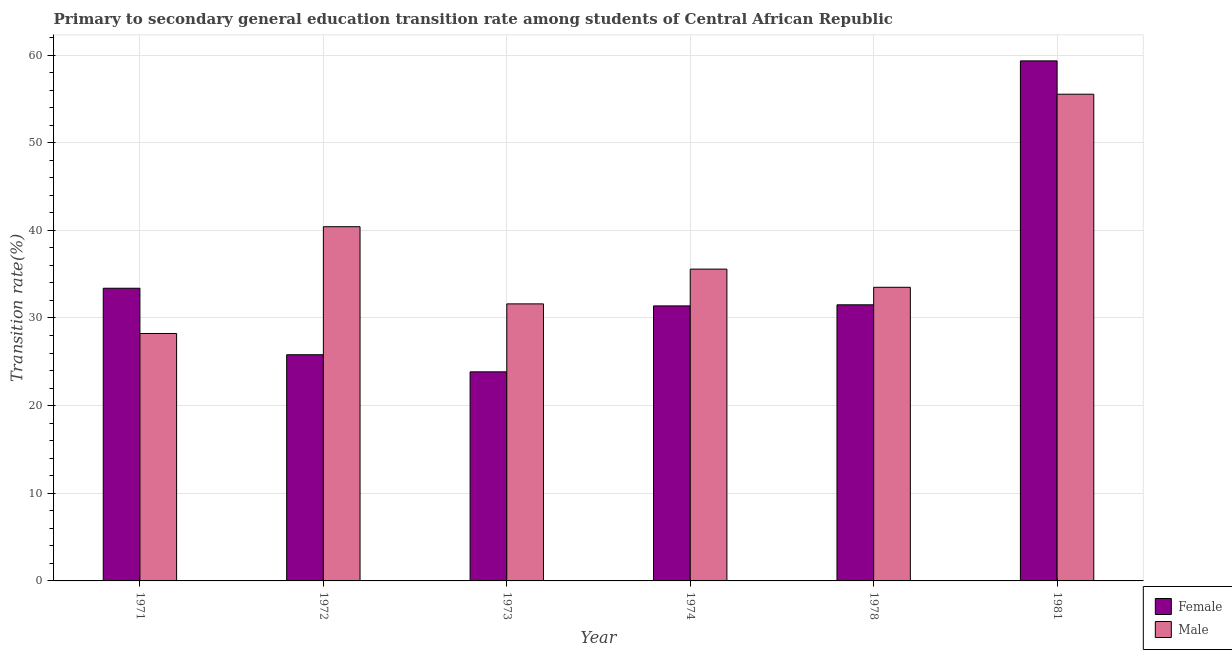How many groups of bars are there?
Give a very brief answer. 6. Are the number of bars per tick equal to the number of legend labels?
Your answer should be very brief. Yes. How many bars are there on the 4th tick from the right?
Your answer should be compact. 2. What is the label of the 6th group of bars from the left?
Offer a very short reply. 1981. In how many cases, is the number of bars for a given year not equal to the number of legend labels?
Your answer should be compact. 0. What is the transition rate among female students in 1974?
Provide a succinct answer. 31.38. Across all years, what is the maximum transition rate among male students?
Your response must be concise. 55.53. Across all years, what is the minimum transition rate among female students?
Provide a succinct answer. 23.85. In which year was the transition rate among female students maximum?
Your answer should be compact. 1981. What is the total transition rate among male students in the graph?
Provide a short and direct response. 224.85. What is the difference between the transition rate among male students in 1971 and that in 1978?
Your answer should be compact. -5.27. What is the difference between the transition rate among female students in 1972 and the transition rate among male students in 1981?
Provide a succinct answer. -33.53. What is the average transition rate among female students per year?
Ensure brevity in your answer.  34.21. In the year 1973, what is the difference between the transition rate among male students and transition rate among female students?
Your answer should be very brief. 0. In how many years, is the transition rate among female students greater than 52 %?
Provide a succinct answer. 1. What is the ratio of the transition rate among female students in 1973 to that in 1981?
Your answer should be compact. 0.4. Is the transition rate among female students in 1972 less than that in 1978?
Provide a short and direct response. Yes. What is the difference between the highest and the second highest transition rate among female students?
Keep it short and to the point. 25.94. What is the difference between the highest and the lowest transition rate among male students?
Provide a succinct answer. 27.3. What does the 1st bar from the right in 1973 represents?
Make the answer very short. Male. How many bars are there?
Make the answer very short. 12. Does the graph contain grids?
Offer a terse response. Yes. How are the legend labels stacked?
Offer a very short reply. Vertical. What is the title of the graph?
Keep it short and to the point. Primary to secondary general education transition rate among students of Central African Republic. Does "Money lenders" appear as one of the legend labels in the graph?
Provide a short and direct response. No. What is the label or title of the Y-axis?
Make the answer very short. Transition rate(%). What is the Transition rate(%) in Female in 1971?
Provide a short and direct response. 33.39. What is the Transition rate(%) of Male in 1971?
Offer a very short reply. 28.23. What is the Transition rate(%) in Female in 1972?
Provide a short and direct response. 25.81. What is the Transition rate(%) in Male in 1972?
Provide a short and direct response. 40.41. What is the Transition rate(%) of Female in 1973?
Ensure brevity in your answer.  23.85. What is the Transition rate(%) in Male in 1973?
Your response must be concise. 31.61. What is the Transition rate(%) in Female in 1974?
Ensure brevity in your answer.  31.38. What is the Transition rate(%) in Male in 1974?
Ensure brevity in your answer.  35.57. What is the Transition rate(%) in Female in 1978?
Provide a succinct answer. 31.5. What is the Transition rate(%) in Male in 1978?
Offer a very short reply. 33.5. What is the Transition rate(%) of Female in 1981?
Your response must be concise. 59.33. What is the Transition rate(%) in Male in 1981?
Your response must be concise. 55.53. Across all years, what is the maximum Transition rate(%) in Female?
Ensure brevity in your answer.  59.33. Across all years, what is the maximum Transition rate(%) in Male?
Make the answer very short. 55.53. Across all years, what is the minimum Transition rate(%) of Female?
Your answer should be very brief. 23.85. Across all years, what is the minimum Transition rate(%) of Male?
Provide a short and direct response. 28.23. What is the total Transition rate(%) of Female in the graph?
Your response must be concise. 205.26. What is the total Transition rate(%) of Male in the graph?
Make the answer very short. 224.85. What is the difference between the Transition rate(%) in Female in 1971 and that in 1972?
Provide a succinct answer. 7.58. What is the difference between the Transition rate(%) in Male in 1971 and that in 1972?
Ensure brevity in your answer.  -12.18. What is the difference between the Transition rate(%) of Female in 1971 and that in 1973?
Make the answer very short. 9.54. What is the difference between the Transition rate(%) in Male in 1971 and that in 1973?
Ensure brevity in your answer.  -3.38. What is the difference between the Transition rate(%) in Female in 1971 and that in 1974?
Your response must be concise. 2.01. What is the difference between the Transition rate(%) in Male in 1971 and that in 1974?
Your answer should be very brief. -7.34. What is the difference between the Transition rate(%) of Female in 1971 and that in 1978?
Your answer should be very brief. 1.89. What is the difference between the Transition rate(%) of Male in 1971 and that in 1978?
Make the answer very short. -5.27. What is the difference between the Transition rate(%) in Female in 1971 and that in 1981?
Your answer should be very brief. -25.94. What is the difference between the Transition rate(%) of Male in 1971 and that in 1981?
Your answer should be compact. -27.3. What is the difference between the Transition rate(%) of Female in 1972 and that in 1973?
Provide a short and direct response. 1.95. What is the difference between the Transition rate(%) in Male in 1972 and that in 1973?
Provide a short and direct response. 8.8. What is the difference between the Transition rate(%) in Female in 1972 and that in 1974?
Your answer should be compact. -5.57. What is the difference between the Transition rate(%) in Male in 1972 and that in 1974?
Offer a terse response. 4.84. What is the difference between the Transition rate(%) in Female in 1972 and that in 1978?
Your answer should be compact. -5.7. What is the difference between the Transition rate(%) of Male in 1972 and that in 1978?
Provide a short and direct response. 6.91. What is the difference between the Transition rate(%) of Female in 1972 and that in 1981?
Your answer should be compact. -33.53. What is the difference between the Transition rate(%) of Male in 1972 and that in 1981?
Keep it short and to the point. -15.12. What is the difference between the Transition rate(%) in Female in 1973 and that in 1974?
Provide a short and direct response. -7.52. What is the difference between the Transition rate(%) in Male in 1973 and that in 1974?
Your response must be concise. -3.97. What is the difference between the Transition rate(%) of Female in 1973 and that in 1978?
Offer a terse response. -7.65. What is the difference between the Transition rate(%) in Male in 1973 and that in 1978?
Ensure brevity in your answer.  -1.89. What is the difference between the Transition rate(%) of Female in 1973 and that in 1981?
Your response must be concise. -35.48. What is the difference between the Transition rate(%) of Male in 1973 and that in 1981?
Your answer should be very brief. -23.92. What is the difference between the Transition rate(%) of Female in 1974 and that in 1978?
Your response must be concise. -0.12. What is the difference between the Transition rate(%) in Male in 1974 and that in 1978?
Ensure brevity in your answer.  2.07. What is the difference between the Transition rate(%) in Female in 1974 and that in 1981?
Keep it short and to the point. -27.96. What is the difference between the Transition rate(%) in Male in 1974 and that in 1981?
Your answer should be very brief. -19.95. What is the difference between the Transition rate(%) of Female in 1978 and that in 1981?
Make the answer very short. -27.83. What is the difference between the Transition rate(%) in Male in 1978 and that in 1981?
Offer a very short reply. -22.03. What is the difference between the Transition rate(%) in Female in 1971 and the Transition rate(%) in Male in 1972?
Give a very brief answer. -7.02. What is the difference between the Transition rate(%) in Female in 1971 and the Transition rate(%) in Male in 1973?
Make the answer very short. 1.78. What is the difference between the Transition rate(%) in Female in 1971 and the Transition rate(%) in Male in 1974?
Your answer should be very brief. -2.18. What is the difference between the Transition rate(%) of Female in 1971 and the Transition rate(%) of Male in 1978?
Ensure brevity in your answer.  -0.11. What is the difference between the Transition rate(%) in Female in 1971 and the Transition rate(%) in Male in 1981?
Make the answer very short. -22.14. What is the difference between the Transition rate(%) in Female in 1972 and the Transition rate(%) in Male in 1973?
Offer a very short reply. -5.8. What is the difference between the Transition rate(%) in Female in 1972 and the Transition rate(%) in Male in 1974?
Ensure brevity in your answer.  -9.77. What is the difference between the Transition rate(%) in Female in 1972 and the Transition rate(%) in Male in 1978?
Your response must be concise. -7.69. What is the difference between the Transition rate(%) in Female in 1972 and the Transition rate(%) in Male in 1981?
Ensure brevity in your answer.  -29.72. What is the difference between the Transition rate(%) of Female in 1973 and the Transition rate(%) of Male in 1974?
Your response must be concise. -11.72. What is the difference between the Transition rate(%) in Female in 1973 and the Transition rate(%) in Male in 1978?
Keep it short and to the point. -9.65. What is the difference between the Transition rate(%) of Female in 1973 and the Transition rate(%) of Male in 1981?
Offer a terse response. -31.68. What is the difference between the Transition rate(%) in Female in 1974 and the Transition rate(%) in Male in 1978?
Your response must be concise. -2.12. What is the difference between the Transition rate(%) of Female in 1974 and the Transition rate(%) of Male in 1981?
Provide a short and direct response. -24.15. What is the difference between the Transition rate(%) of Female in 1978 and the Transition rate(%) of Male in 1981?
Offer a very short reply. -24.03. What is the average Transition rate(%) of Female per year?
Your answer should be very brief. 34.21. What is the average Transition rate(%) of Male per year?
Offer a very short reply. 37.48. In the year 1971, what is the difference between the Transition rate(%) in Female and Transition rate(%) in Male?
Offer a very short reply. 5.16. In the year 1972, what is the difference between the Transition rate(%) of Female and Transition rate(%) of Male?
Your answer should be compact. -14.61. In the year 1973, what is the difference between the Transition rate(%) in Female and Transition rate(%) in Male?
Your response must be concise. -7.75. In the year 1974, what is the difference between the Transition rate(%) of Female and Transition rate(%) of Male?
Provide a short and direct response. -4.2. In the year 1978, what is the difference between the Transition rate(%) in Female and Transition rate(%) in Male?
Provide a short and direct response. -2. In the year 1981, what is the difference between the Transition rate(%) in Female and Transition rate(%) in Male?
Give a very brief answer. 3.8. What is the ratio of the Transition rate(%) of Female in 1971 to that in 1972?
Your answer should be very brief. 1.29. What is the ratio of the Transition rate(%) in Male in 1971 to that in 1972?
Keep it short and to the point. 0.7. What is the ratio of the Transition rate(%) in Female in 1971 to that in 1973?
Your answer should be compact. 1.4. What is the ratio of the Transition rate(%) of Male in 1971 to that in 1973?
Ensure brevity in your answer.  0.89. What is the ratio of the Transition rate(%) of Female in 1971 to that in 1974?
Your answer should be very brief. 1.06. What is the ratio of the Transition rate(%) of Male in 1971 to that in 1974?
Provide a short and direct response. 0.79. What is the ratio of the Transition rate(%) in Female in 1971 to that in 1978?
Make the answer very short. 1.06. What is the ratio of the Transition rate(%) of Male in 1971 to that in 1978?
Your answer should be compact. 0.84. What is the ratio of the Transition rate(%) of Female in 1971 to that in 1981?
Provide a succinct answer. 0.56. What is the ratio of the Transition rate(%) in Male in 1971 to that in 1981?
Offer a terse response. 0.51. What is the ratio of the Transition rate(%) in Female in 1972 to that in 1973?
Offer a very short reply. 1.08. What is the ratio of the Transition rate(%) of Male in 1972 to that in 1973?
Offer a terse response. 1.28. What is the ratio of the Transition rate(%) of Female in 1972 to that in 1974?
Offer a very short reply. 0.82. What is the ratio of the Transition rate(%) in Male in 1972 to that in 1974?
Give a very brief answer. 1.14. What is the ratio of the Transition rate(%) in Female in 1972 to that in 1978?
Provide a short and direct response. 0.82. What is the ratio of the Transition rate(%) of Male in 1972 to that in 1978?
Provide a short and direct response. 1.21. What is the ratio of the Transition rate(%) in Female in 1972 to that in 1981?
Offer a very short reply. 0.43. What is the ratio of the Transition rate(%) of Male in 1972 to that in 1981?
Your answer should be very brief. 0.73. What is the ratio of the Transition rate(%) of Female in 1973 to that in 1974?
Your response must be concise. 0.76. What is the ratio of the Transition rate(%) in Male in 1973 to that in 1974?
Your answer should be very brief. 0.89. What is the ratio of the Transition rate(%) in Female in 1973 to that in 1978?
Give a very brief answer. 0.76. What is the ratio of the Transition rate(%) of Male in 1973 to that in 1978?
Make the answer very short. 0.94. What is the ratio of the Transition rate(%) of Female in 1973 to that in 1981?
Make the answer very short. 0.4. What is the ratio of the Transition rate(%) of Male in 1973 to that in 1981?
Your answer should be compact. 0.57. What is the ratio of the Transition rate(%) in Female in 1974 to that in 1978?
Offer a terse response. 1. What is the ratio of the Transition rate(%) in Male in 1974 to that in 1978?
Give a very brief answer. 1.06. What is the ratio of the Transition rate(%) in Female in 1974 to that in 1981?
Offer a terse response. 0.53. What is the ratio of the Transition rate(%) of Male in 1974 to that in 1981?
Your answer should be very brief. 0.64. What is the ratio of the Transition rate(%) in Female in 1978 to that in 1981?
Your answer should be compact. 0.53. What is the ratio of the Transition rate(%) in Male in 1978 to that in 1981?
Your answer should be very brief. 0.6. What is the difference between the highest and the second highest Transition rate(%) in Female?
Your answer should be compact. 25.94. What is the difference between the highest and the second highest Transition rate(%) of Male?
Ensure brevity in your answer.  15.12. What is the difference between the highest and the lowest Transition rate(%) of Female?
Make the answer very short. 35.48. What is the difference between the highest and the lowest Transition rate(%) of Male?
Your answer should be compact. 27.3. 